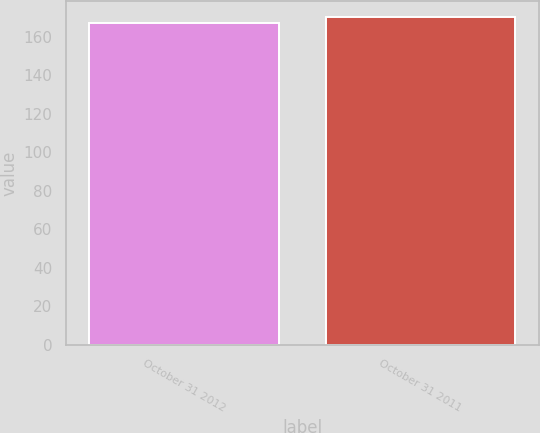<chart> <loc_0><loc_0><loc_500><loc_500><bar_chart><fcel>October 31 2012<fcel>October 31 2011<nl><fcel>167<fcel>170<nl></chart> 